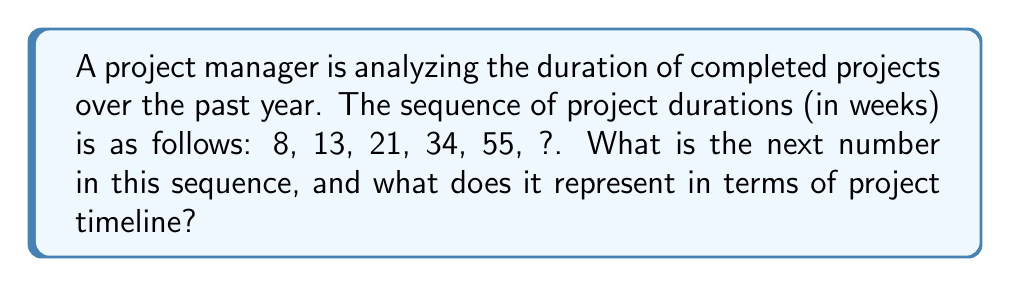Can you solve this math problem? To solve this problem, let's follow these steps:

1. Analyze the given sequence: 8, 13, 21, 34, 55, ?

2. Look for a pattern in the differences between consecutive terms:
   $13 - 8 = 5$
   $21 - 13 = 8$
   $34 - 21 = 13$
   $55 - 34 = 21$

3. We can observe that each difference is the sum of the previous two terms:
   $5 + 8 = 13$
   $8 + 13 = 21$
   $13 + 21 = 34$

4. This pattern follows the Fibonacci sequence, where each number is the sum of the two preceding ones.

5. To find the next number in the sequence, we add the last two terms:
   $55 + 34 = 89$

6. Therefore, the next number in the sequence is 89.

In the context of project timelines, this sequence represents increasingly longer project durations. The next project in this trend would be expected to last 89 weeks, which is approximately 1 year and 9 months.

This pattern could be useful for the project manager to anticipate and plan for longer project durations in the future, allowing for better resource allocation and timeline estimations.
Answer: 89 weeks 